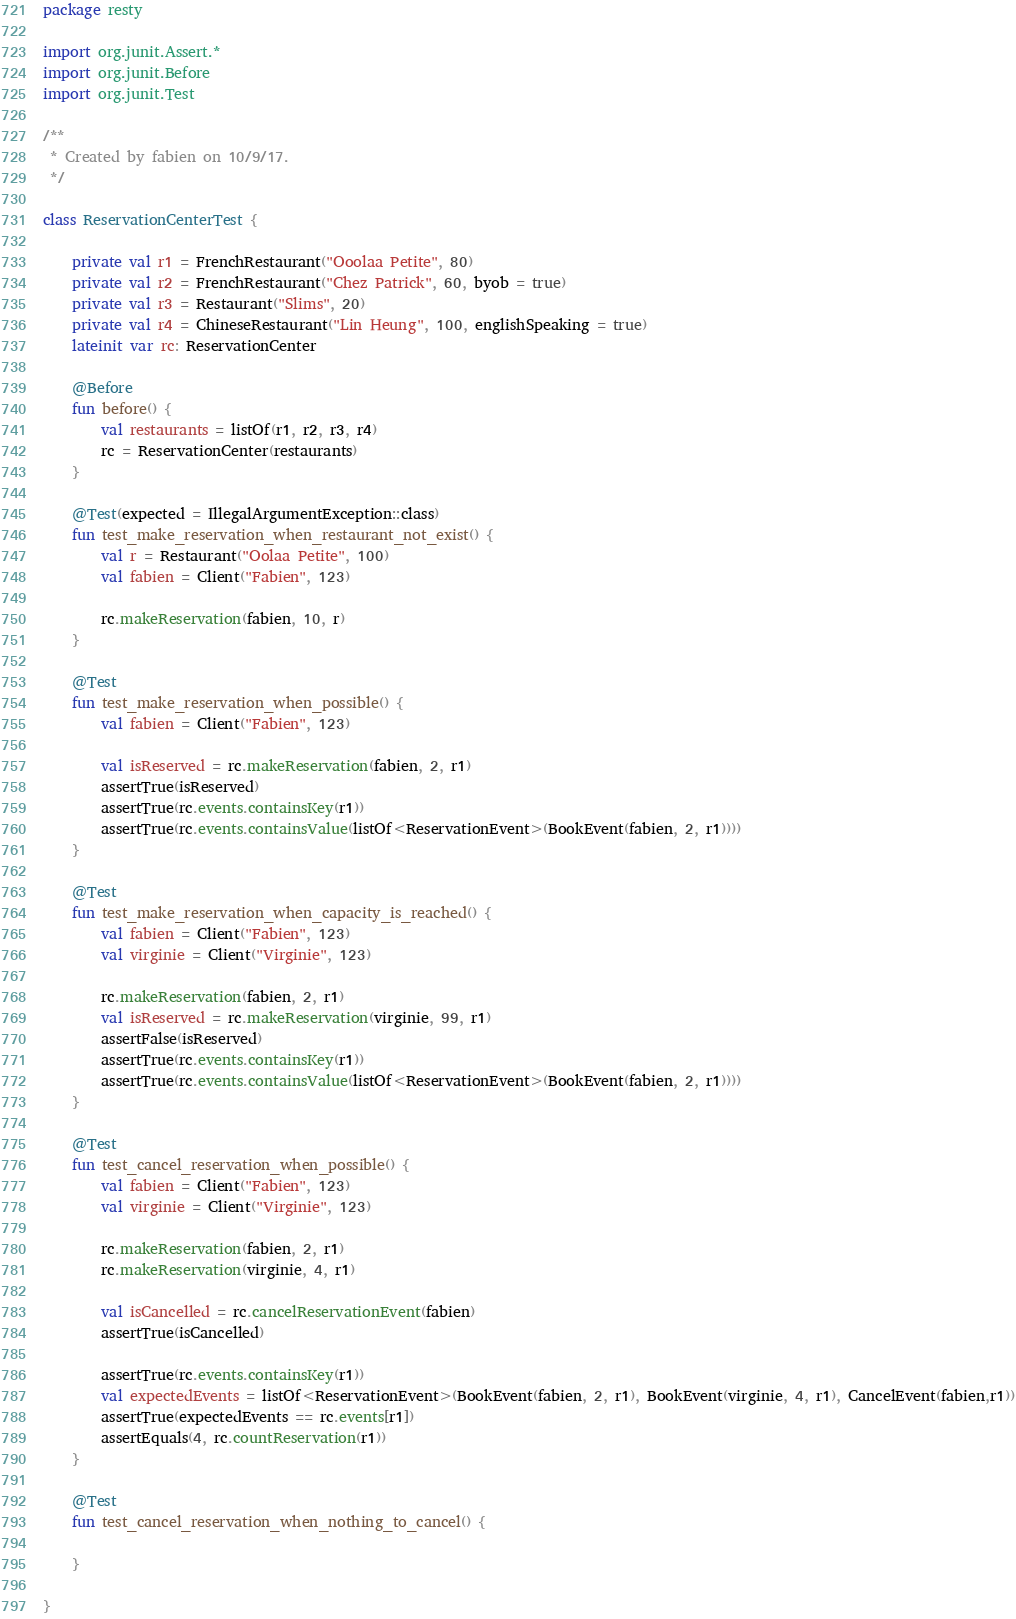<code> <loc_0><loc_0><loc_500><loc_500><_Kotlin_>package resty

import org.junit.Assert.*
import org.junit.Before
import org.junit.Test

/**
 * Created by fabien on 10/9/17.
 */

class ReservationCenterTest {

    private val r1 = FrenchRestaurant("Ooolaa Petite", 80)
    private val r2 = FrenchRestaurant("Chez Patrick", 60, byob = true)
    private val r3 = Restaurant("Slims", 20)
    private val r4 = ChineseRestaurant("Lin Heung", 100, englishSpeaking = true)
    lateinit var rc: ReservationCenter

    @Before
    fun before() {
        val restaurants = listOf(r1, r2, r3, r4)
        rc = ReservationCenter(restaurants)
    }

    @Test(expected = IllegalArgumentException::class)
    fun test_make_reservation_when_restaurant_not_exist() {
        val r = Restaurant("Oolaa Petite", 100)
        val fabien = Client("Fabien", 123)

        rc.makeReservation(fabien, 10, r)
    }

    @Test
    fun test_make_reservation_when_possible() {
        val fabien = Client("Fabien", 123)

        val isReserved = rc.makeReservation(fabien, 2, r1)
        assertTrue(isReserved)
        assertTrue(rc.events.containsKey(r1))
        assertTrue(rc.events.containsValue(listOf<ReservationEvent>(BookEvent(fabien, 2, r1))))
    }

    @Test
    fun test_make_reservation_when_capacity_is_reached() {
        val fabien = Client("Fabien", 123)
        val virginie = Client("Virginie", 123)

        rc.makeReservation(fabien, 2, r1)
        val isReserved = rc.makeReservation(virginie, 99, r1)
        assertFalse(isReserved)
        assertTrue(rc.events.containsKey(r1))
        assertTrue(rc.events.containsValue(listOf<ReservationEvent>(BookEvent(fabien, 2, r1))))
    }

    @Test
    fun test_cancel_reservation_when_possible() {
        val fabien = Client("Fabien", 123)
        val virginie = Client("Virginie", 123)

        rc.makeReservation(fabien, 2, r1)
        rc.makeReservation(virginie, 4, r1)

        val isCancelled = rc.cancelReservationEvent(fabien)
        assertTrue(isCancelled)

        assertTrue(rc.events.containsKey(r1))
        val expectedEvents = listOf<ReservationEvent>(BookEvent(fabien, 2, r1), BookEvent(virginie, 4, r1), CancelEvent(fabien,r1))
        assertTrue(expectedEvents == rc.events[r1])
        assertEquals(4, rc.countReservation(r1))
    }

    @Test
    fun test_cancel_reservation_when_nothing_to_cancel() {

    }

}
</code> 